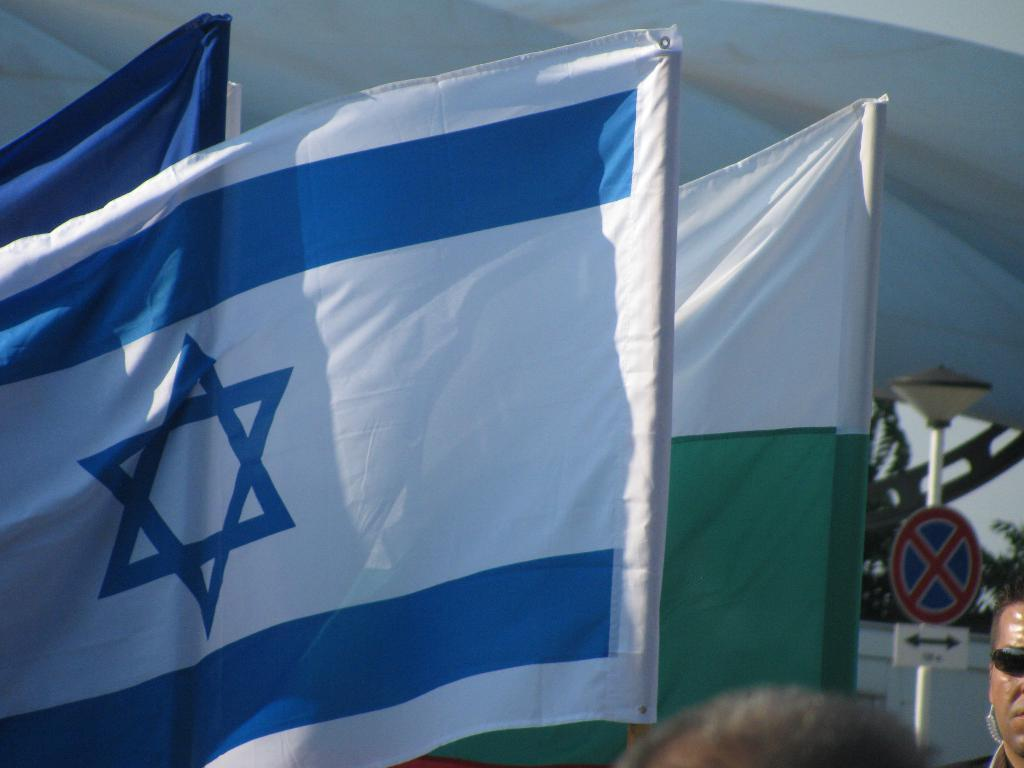What can be seen in the image that represents a symbol or country? There are flags in the image. What are the flags attached to in the image? There are poles in the image. What other objects can be seen in the image? There are boards, a wall, and branches visible in the image. What is the color of the sky in the image? The sky is visible in the image, but the color is not mentioned in the facts. How many partially visible persons are in the image? There are two partially visible persons in the image. What is the background of the image? There is a white background in the image. What type of blade is being used by the sister in the image? There is no sister or blade present in the image. How does the self-awareness of the persons in the image affect their actions? The facts do not mention self-awareness or any actions of the persons in the image. 